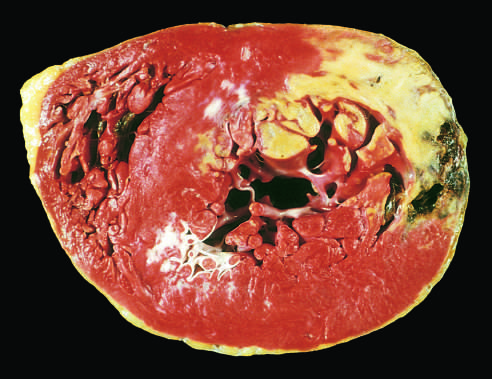how did acute myocardial infarct of the posterolateral left ventricle demonstrate?
Answer the question using a single word or phrase. By a lack of triphenyltetrazolium chloride staining in areas of necrosis 